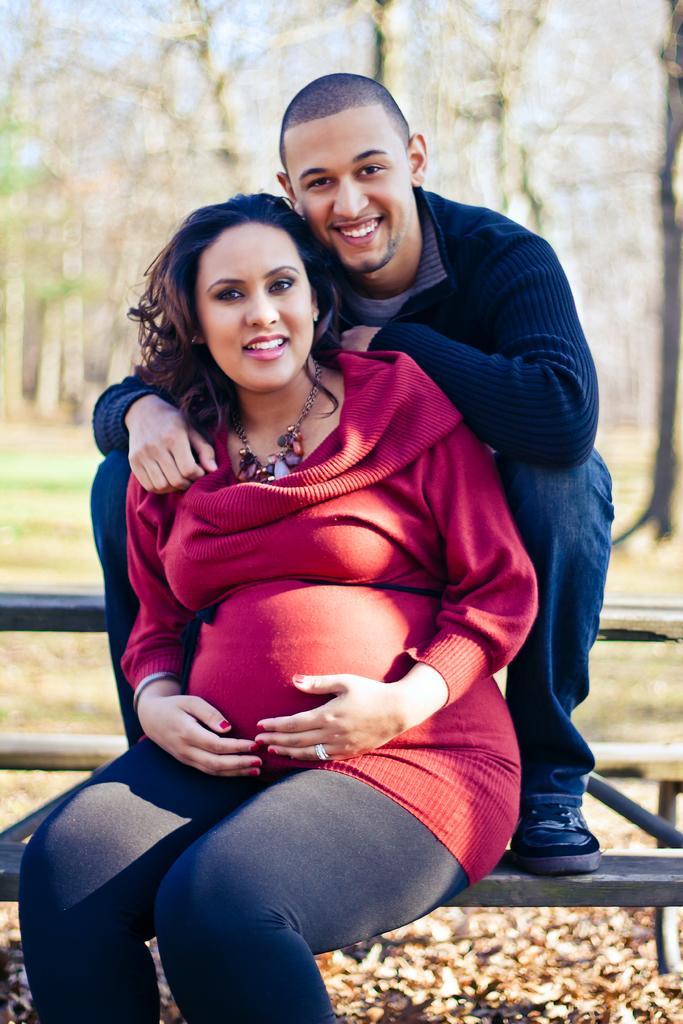Could you give a brief overview of what you see in this image? In this image we can see a lady, and a man sitting on the bench, behind them there are trees, and the background is blurred. 